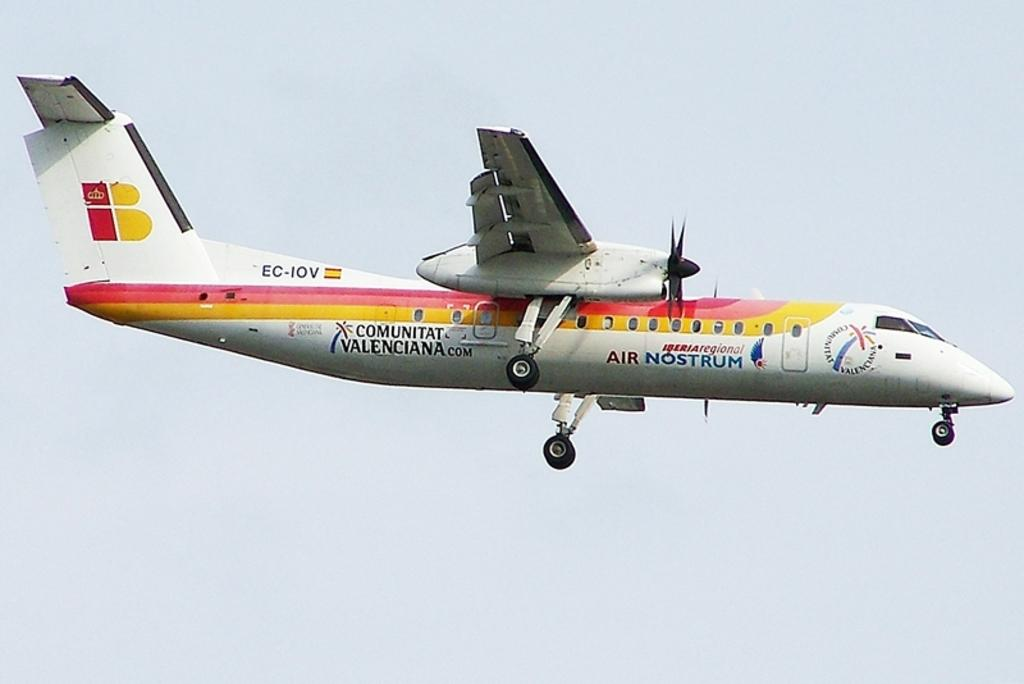What is the main subject of the image? The main subject of the image is an airplane. What is the airplane doing in the image? The airplane is flying in the sky. What type of blade can be seen cutting through the jelly in the image? There is no blade or jelly present in the image; it features an airplane flying in the sky. 